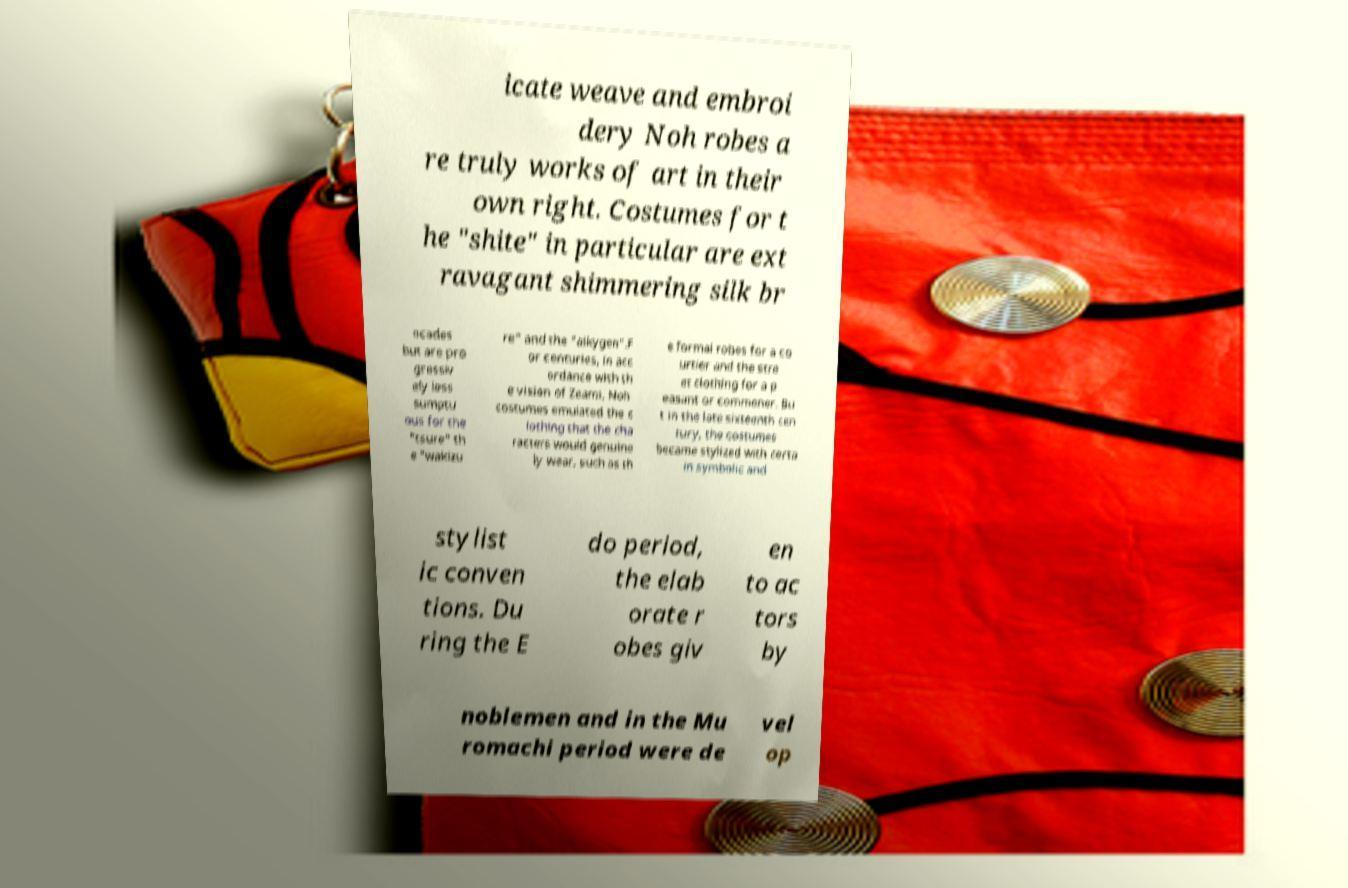There's text embedded in this image that I need extracted. Can you transcribe it verbatim? icate weave and embroi dery Noh robes a re truly works of art in their own right. Costumes for t he "shite" in particular are ext ravagant shimmering silk br ocades but are pro gressiv ely less sumptu ous for the "tsure" th e "wakizu re" and the "aikygen".F or centuries, in acc ordance with th e vision of Zeami, Noh costumes emulated the c lothing that the cha racters would genuine ly wear, such as th e formal robes for a co urtier and the stre et clothing for a p easant or commoner. Bu t in the late sixteenth cen tury, the costumes became stylized with certa in symbolic and stylist ic conven tions. Du ring the E do period, the elab orate r obes giv en to ac tors by noblemen and in the Mu romachi period were de vel op 